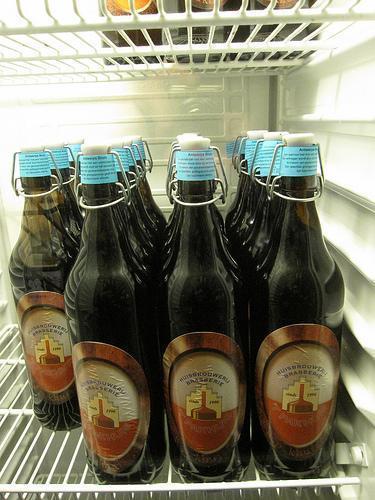How many bottles are in the picture?
Give a very brief answer. 15. 